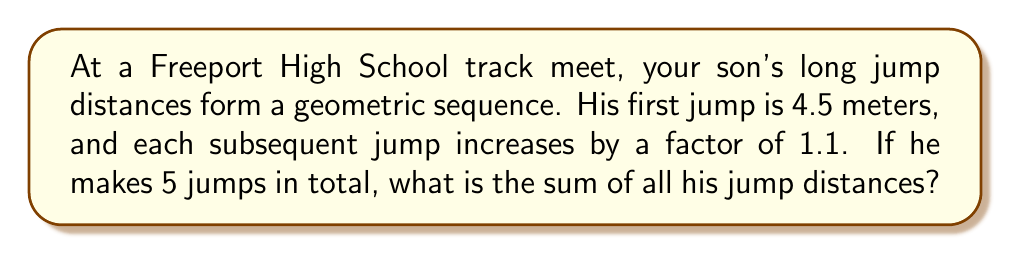Could you help me with this problem? Let's approach this step-by-step:

1) We're dealing with a geometric sequence where:
   - First term, $a = 4.5$ meters
   - Common ratio, $r = 1.1$
   - Number of terms, $n = 5$

2) The formula for the sum of a geometric sequence is:
   
   $$S_n = \frac{a(1-r^n)}{1-r}$$

   Where $S_n$ is the sum of $n$ terms.

3) Let's substitute our values:

   $$S_5 = \frac{4.5(1-1.1^5)}{1-1.1}$$

4) Calculate $1.1^5$:
   
   $$1.1^5 = 1.6105$$

5) Now our equation looks like:

   $$S_5 = \frac{4.5(1-1.6105)}{1-1.1} = \frac{4.5(-0.6105)}{-0.1}$$

6) Simplify:

   $$S_5 = \frac{2.74725}{0.1} = 27.4725$$

7) Round to two decimal places:

   $$S_5 \approx 27.47 \text{ meters}$$
Answer: $27.47$ meters 